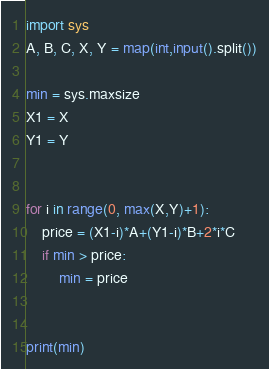<code> <loc_0><loc_0><loc_500><loc_500><_Python_>import sys
A, B, C, X, Y = map(int,input().split())

min = sys.maxsize
X1 = X
Y1 = Y


for i in range(0, max(X,Y)+1):
    price = (X1-i)*A+(Y1-i)*B+2*i*C
    if min > price:
        min = price


print(min)
</code> 